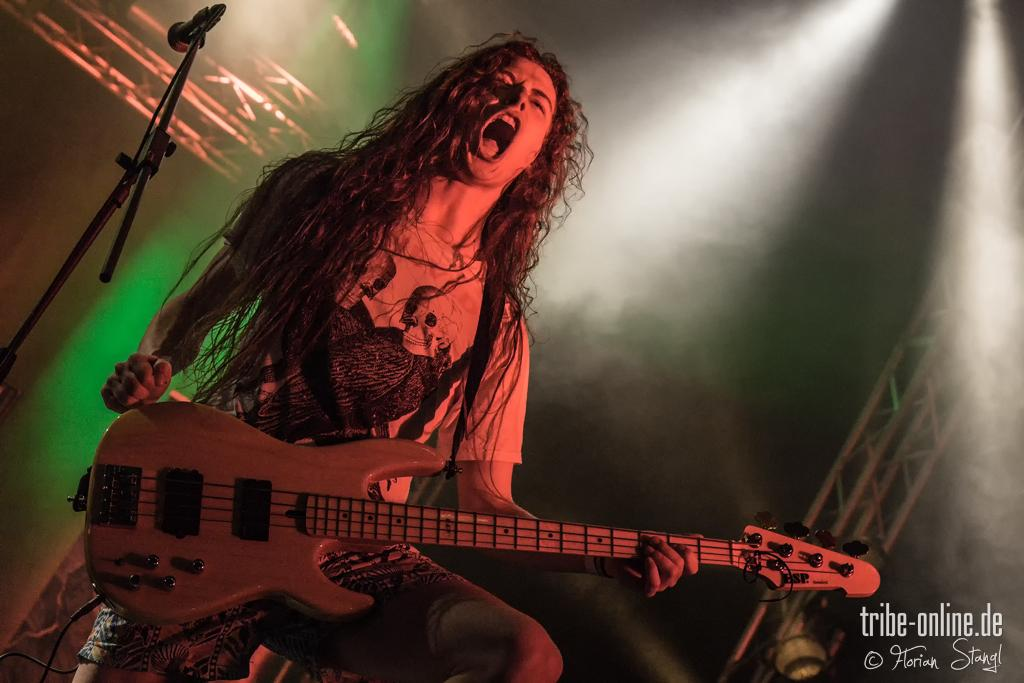What type of event is taking place in the image? The image is taken at a musical concert. What instrument is the man holding in the image? The man is holding a guitar in his hands. What is the man doing with the guitar? The man is playing the guitar. What is the man doing besides playing the guitar? The man is singing. What device is beside the man that might be used for amplifying his voice? There is a microphone beside the man. What type of grain can be seen growing in the background of the image? There is no grain visible in the image, as it is taken at a musical concert and does not depict any agricultural scenes. 